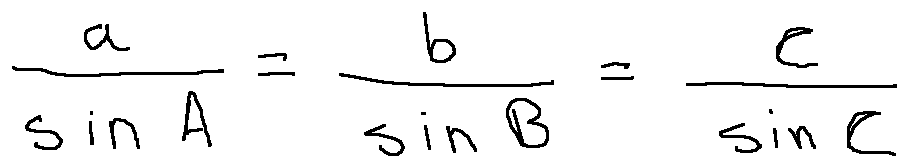<formula> <loc_0><loc_0><loc_500><loc_500>\frac { a } { \sin A } = \frac { b } { \sin B } = \frac { c } { \sin C }</formula> 